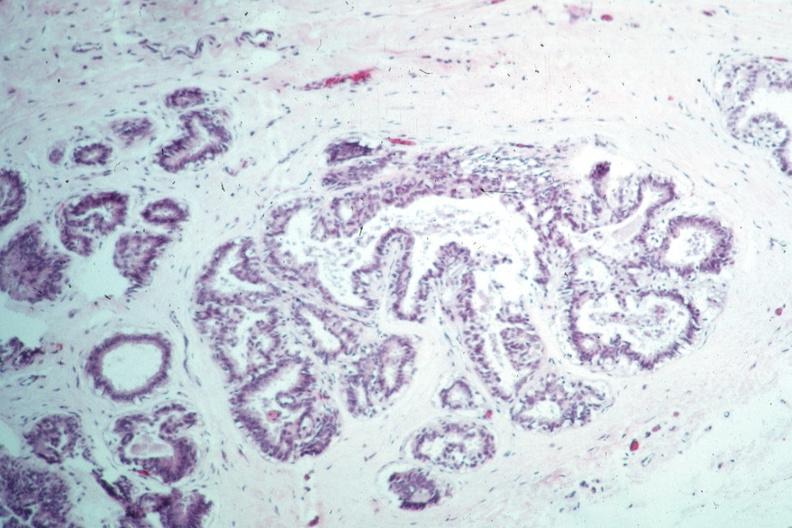how does this image appear?
Answer the question using a single word or phrase. Benign 